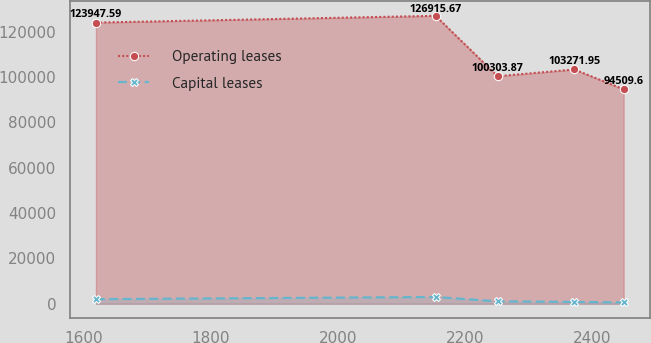Convert chart to OTSL. <chart><loc_0><loc_0><loc_500><loc_500><line_chart><ecel><fcel>Operating leases<fcel>Capital leases<nl><fcel>1619.85<fcel>123948<fcel>2023.42<nl><fcel>2154.02<fcel>126916<fcel>2989.27<nl><fcel>2251.44<fcel>100304<fcel>1065.61<nl><fcel>2372.16<fcel>103272<fcel>825.15<nl><fcel>2449.84<fcel>94509.6<fcel>584.69<nl></chart> 